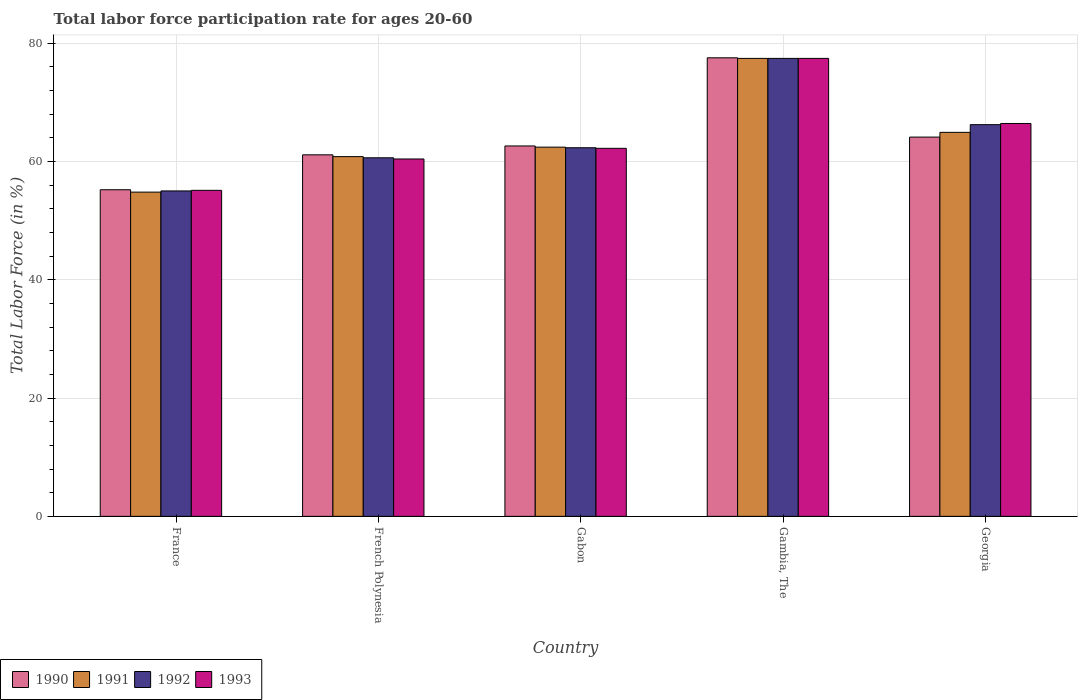How many different coloured bars are there?
Your answer should be compact. 4. How many groups of bars are there?
Provide a short and direct response. 5. Are the number of bars on each tick of the X-axis equal?
Provide a short and direct response. Yes. How many bars are there on the 5th tick from the left?
Your answer should be compact. 4. What is the label of the 4th group of bars from the left?
Your answer should be very brief. Gambia, The. What is the labor force participation rate in 1992 in France?
Keep it short and to the point. 55. Across all countries, what is the maximum labor force participation rate in 1992?
Your answer should be compact. 77.4. Across all countries, what is the minimum labor force participation rate in 1990?
Keep it short and to the point. 55.2. In which country was the labor force participation rate in 1990 maximum?
Offer a very short reply. Gambia, The. What is the total labor force participation rate in 1991 in the graph?
Your answer should be very brief. 320.3. What is the difference between the labor force participation rate in 1991 in France and that in Georgia?
Your response must be concise. -10.1. What is the difference between the labor force participation rate in 1990 in French Polynesia and the labor force participation rate in 1991 in Gabon?
Offer a terse response. -1.3. What is the average labor force participation rate in 1990 per country?
Make the answer very short. 64.1. What is the difference between the labor force participation rate of/in 1990 and labor force participation rate of/in 1993 in French Polynesia?
Provide a succinct answer. 0.7. In how many countries, is the labor force participation rate in 1992 greater than 64 %?
Your answer should be very brief. 2. What is the ratio of the labor force participation rate in 1991 in France to that in Gabon?
Your response must be concise. 0.88. Is the labor force participation rate in 1991 in French Polynesia less than that in Gambia, The?
Give a very brief answer. Yes. Is the difference between the labor force participation rate in 1990 in France and Gabon greater than the difference between the labor force participation rate in 1993 in France and Gabon?
Provide a short and direct response. No. What is the difference between the highest and the second highest labor force participation rate in 1991?
Your answer should be very brief. -12.5. What is the difference between the highest and the lowest labor force participation rate in 1993?
Offer a very short reply. 22.3. In how many countries, is the labor force participation rate in 1991 greater than the average labor force participation rate in 1991 taken over all countries?
Give a very brief answer. 2. Is the sum of the labor force participation rate in 1993 in France and Georgia greater than the maximum labor force participation rate in 1990 across all countries?
Provide a short and direct response. Yes. What does the 4th bar from the left in French Polynesia represents?
Provide a succinct answer. 1993. What does the 2nd bar from the right in Gambia, The represents?
Your answer should be very brief. 1992. How many countries are there in the graph?
Your answer should be very brief. 5. What is the difference between two consecutive major ticks on the Y-axis?
Make the answer very short. 20. Are the values on the major ticks of Y-axis written in scientific E-notation?
Keep it short and to the point. No. Does the graph contain grids?
Make the answer very short. Yes. Where does the legend appear in the graph?
Give a very brief answer. Bottom left. How many legend labels are there?
Ensure brevity in your answer.  4. What is the title of the graph?
Provide a succinct answer. Total labor force participation rate for ages 20-60. What is the label or title of the X-axis?
Make the answer very short. Country. What is the label or title of the Y-axis?
Your answer should be compact. Total Labor Force (in %). What is the Total Labor Force (in %) in 1990 in France?
Your response must be concise. 55.2. What is the Total Labor Force (in %) of 1991 in France?
Offer a very short reply. 54.8. What is the Total Labor Force (in %) of 1993 in France?
Offer a terse response. 55.1. What is the Total Labor Force (in %) of 1990 in French Polynesia?
Make the answer very short. 61.1. What is the Total Labor Force (in %) of 1991 in French Polynesia?
Provide a short and direct response. 60.8. What is the Total Labor Force (in %) in 1992 in French Polynesia?
Make the answer very short. 60.6. What is the Total Labor Force (in %) in 1993 in French Polynesia?
Provide a succinct answer. 60.4. What is the Total Labor Force (in %) in 1990 in Gabon?
Make the answer very short. 62.6. What is the Total Labor Force (in %) of 1991 in Gabon?
Offer a terse response. 62.4. What is the Total Labor Force (in %) of 1992 in Gabon?
Offer a very short reply. 62.3. What is the Total Labor Force (in %) of 1993 in Gabon?
Make the answer very short. 62.2. What is the Total Labor Force (in %) in 1990 in Gambia, The?
Your response must be concise. 77.5. What is the Total Labor Force (in %) of 1991 in Gambia, The?
Provide a succinct answer. 77.4. What is the Total Labor Force (in %) of 1992 in Gambia, The?
Your response must be concise. 77.4. What is the Total Labor Force (in %) in 1993 in Gambia, The?
Make the answer very short. 77.4. What is the Total Labor Force (in %) of 1990 in Georgia?
Give a very brief answer. 64.1. What is the Total Labor Force (in %) in 1991 in Georgia?
Your answer should be very brief. 64.9. What is the Total Labor Force (in %) in 1992 in Georgia?
Ensure brevity in your answer.  66.2. What is the Total Labor Force (in %) in 1993 in Georgia?
Keep it short and to the point. 66.4. Across all countries, what is the maximum Total Labor Force (in %) in 1990?
Offer a very short reply. 77.5. Across all countries, what is the maximum Total Labor Force (in %) of 1991?
Ensure brevity in your answer.  77.4. Across all countries, what is the maximum Total Labor Force (in %) of 1992?
Ensure brevity in your answer.  77.4. Across all countries, what is the maximum Total Labor Force (in %) in 1993?
Give a very brief answer. 77.4. Across all countries, what is the minimum Total Labor Force (in %) in 1990?
Offer a very short reply. 55.2. Across all countries, what is the minimum Total Labor Force (in %) in 1991?
Your response must be concise. 54.8. Across all countries, what is the minimum Total Labor Force (in %) in 1992?
Ensure brevity in your answer.  55. Across all countries, what is the minimum Total Labor Force (in %) of 1993?
Your response must be concise. 55.1. What is the total Total Labor Force (in %) of 1990 in the graph?
Your response must be concise. 320.5. What is the total Total Labor Force (in %) of 1991 in the graph?
Your answer should be compact. 320.3. What is the total Total Labor Force (in %) in 1992 in the graph?
Give a very brief answer. 321.5. What is the total Total Labor Force (in %) of 1993 in the graph?
Offer a very short reply. 321.5. What is the difference between the Total Labor Force (in %) in 1990 in France and that in French Polynesia?
Make the answer very short. -5.9. What is the difference between the Total Labor Force (in %) in 1992 in France and that in French Polynesia?
Your answer should be compact. -5.6. What is the difference between the Total Labor Force (in %) in 1993 in France and that in French Polynesia?
Offer a very short reply. -5.3. What is the difference between the Total Labor Force (in %) in 1992 in France and that in Gabon?
Your response must be concise. -7.3. What is the difference between the Total Labor Force (in %) in 1990 in France and that in Gambia, The?
Your answer should be compact. -22.3. What is the difference between the Total Labor Force (in %) of 1991 in France and that in Gambia, The?
Provide a succinct answer. -22.6. What is the difference between the Total Labor Force (in %) in 1992 in France and that in Gambia, The?
Your response must be concise. -22.4. What is the difference between the Total Labor Force (in %) of 1993 in France and that in Gambia, The?
Your answer should be very brief. -22.3. What is the difference between the Total Labor Force (in %) of 1991 in French Polynesia and that in Gabon?
Offer a terse response. -1.6. What is the difference between the Total Labor Force (in %) in 1992 in French Polynesia and that in Gabon?
Your answer should be very brief. -1.7. What is the difference between the Total Labor Force (in %) in 1990 in French Polynesia and that in Gambia, The?
Offer a very short reply. -16.4. What is the difference between the Total Labor Force (in %) in 1991 in French Polynesia and that in Gambia, The?
Ensure brevity in your answer.  -16.6. What is the difference between the Total Labor Force (in %) in 1992 in French Polynesia and that in Gambia, The?
Offer a terse response. -16.8. What is the difference between the Total Labor Force (in %) of 1993 in French Polynesia and that in Gambia, The?
Provide a succinct answer. -17. What is the difference between the Total Labor Force (in %) of 1990 in French Polynesia and that in Georgia?
Provide a short and direct response. -3. What is the difference between the Total Labor Force (in %) in 1990 in Gabon and that in Gambia, The?
Provide a short and direct response. -14.9. What is the difference between the Total Labor Force (in %) of 1991 in Gabon and that in Gambia, The?
Make the answer very short. -15. What is the difference between the Total Labor Force (in %) of 1992 in Gabon and that in Gambia, The?
Provide a succinct answer. -15.1. What is the difference between the Total Labor Force (in %) in 1993 in Gabon and that in Gambia, The?
Offer a very short reply. -15.2. What is the difference between the Total Labor Force (in %) of 1991 in Gabon and that in Georgia?
Your answer should be very brief. -2.5. What is the difference between the Total Labor Force (in %) of 1990 in Gambia, The and that in Georgia?
Keep it short and to the point. 13.4. What is the difference between the Total Labor Force (in %) of 1991 in Gambia, The and that in Georgia?
Provide a succinct answer. 12.5. What is the difference between the Total Labor Force (in %) in 1993 in Gambia, The and that in Georgia?
Your answer should be very brief. 11. What is the difference between the Total Labor Force (in %) in 1990 in France and the Total Labor Force (in %) in 1992 in French Polynesia?
Provide a succinct answer. -5.4. What is the difference between the Total Labor Force (in %) in 1990 in France and the Total Labor Force (in %) in 1993 in French Polynesia?
Your answer should be very brief. -5.2. What is the difference between the Total Labor Force (in %) in 1991 in France and the Total Labor Force (in %) in 1992 in French Polynesia?
Provide a short and direct response. -5.8. What is the difference between the Total Labor Force (in %) in 1991 in France and the Total Labor Force (in %) in 1993 in French Polynesia?
Offer a very short reply. -5.6. What is the difference between the Total Labor Force (in %) of 1992 in France and the Total Labor Force (in %) of 1993 in French Polynesia?
Give a very brief answer. -5.4. What is the difference between the Total Labor Force (in %) in 1990 in France and the Total Labor Force (in %) in 1993 in Gabon?
Provide a short and direct response. -7. What is the difference between the Total Labor Force (in %) of 1991 in France and the Total Labor Force (in %) of 1992 in Gabon?
Make the answer very short. -7.5. What is the difference between the Total Labor Force (in %) in 1991 in France and the Total Labor Force (in %) in 1993 in Gabon?
Give a very brief answer. -7.4. What is the difference between the Total Labor Force (in %) in 1990 in France and the Total Labor Force (in %) in 1991 in Gambia, The?
Offer a very short reply. -22.2. What is the difference between the Total Labor Force (in %) of 1990 in France and the Total Labor Force (in %) of 1992 in Gambia, The?
Give a very brief answer. -22.2. What is the difference between the Total Labor Force (in %) in 1990 in France and the Total Labor Force (in %) in 1993 in Gambia, The?
Provide a succinct answer. -22.2. What is the difference between the Total Labor Force (in %) of 1991 in France and the Total Labor Force (in %) of 1992 in Gambia, The?
Offer a terse response. -22.6. What is the difference between the Total Labor Force (in %) in 1991 in France and the Total Labor Force (in %) in 1993 in Gambia, The?
Your answer should be very brief. -22.6. What is the difference between the Total Labor Force (in %) in 1992 in France and the Total Labor Force (in %) in 1993 in Gambia, The?
Provide a succinct answer. -22.4. What is the difference between the Total Labor Force (in %) in 1991 in France and the Total Labor Force (in %) in 1992 in Georgia?
Keep it short and to the point. -11.4. What is the difference between the Total Labor Force (in %) in 1991 in France and the Total Labor Force (in %) in 1993 in Georgia?
Your answer should be compact. -11.6. What is the difference between the Total Labor Force (in %) of 1992 in French Polynesia and the Total Labor Force (in %) of 1993 in Gabon?
Your answer should be very brief. -1.6. What is the difference between the Total Labor Force (in %) in 1990 in French Polynesia and the Total Labor Force (in %) in 1991 in Gambia, The?
Provide a short and direct response. -16.3. What is the difference between the Total Labor Force (in %) in 1990 in French Polynesia and the Total Labor Force (in %) in 1992 in Gambia, The?
Offer a very short reply. -16.3. What is the difference between the Total Labor Force (in %) of 1990 in French Polynesia and the Total Labor Force (in %) of 1993 in Gambia, The?
Provide a short and direct response. -16.3. What is the difference between the Total Labor Force (in %) of 1991 in French Polynesia and the Total Labor Force (in %) of 1992 in Gambia, The?
Your answer should be compact. -16.6. What is the difference between the Total Labor Force (in %) in 1991 in French Polynesia and the Total Labor Force (in %) in 1993 in Gambia, The?
Provide a succinct answer. -16.6. What is the difference between the Total Labor Force (in %) in 1992 in French Polynesia and the Total Labor Force (in %) in 1993 in Gambia, The?
Offer a very short reply. -16.8. What is the difference between the Total Labor Force (in %) in 1990 in French Polynesia and the Total Labor Force (in %) in 1991 in Georgia?
Offer a very short reply. -3.8. What is the difference between the Total Labor Force (in %) in 1990 in French Polynesia and the Total Labor Force (in %) in 1992 in Georgia?
Your answer should be compact. -5.1. What is the difference between the Total Labor Force (in %) of 1990 in French Polynesia and the Total Labor Force (in %) of 1993 in Georgia?
Offer a very short reply. -5.3. What is the difference between the Total Labor Force (in %) of 1991 in French Polynesia and the Total Labor Force (in %) of 1992 in Georgia?
Ensure brevity in your answer.  -5.4. What is the difference between the Total Labor Force (in %) of 1990 in Gabon and the Total Labor Force (in %) of 1991 in Gambia, The?
Your answer should be compact. -14.8. What is the difference between the Total Labor Force (in %) in 1990 in Gabon and the Total Labor Force (in %) in 1992 in Gambia, The?
Make the answer very short. -14.8. What is the difference between the Total Labor Force (in %) in 1990 in Gabon and the Total Labor Force (in %) in 1993 in Gambia, The?
Make the answer very short. -14.8. What is the difference between the Total Labor Force (in %) of 1991 in Gabon and the Total Labor Force (in %) of 1993 in Gambia, The?
Keep it short and to the point. -15. What is the difference between the Total Labor Force (in %) of 1992 in Gabon and the Total Labor Force (in %) of 1993 in Gambia, The?
Keep it short and to the point. -15.1. What is the difference between the Total Labor Force (in %) in 1990 in Gabon and the Total Labor Force (in %) in 1991 in Georgia?
Make the answer very short. -2.3. What is the difference between the Total Labor Force (in %) in 1990 in Gabon and the Total Labor Force (in %) in 1993 in Georgia?
Your answer should be very brief. -3.8. What is the difference between the Total Labor Force (in %) of 1991 in Gabon and the Total Labor Force (in %) of 1993 in Georgia?
Your answer should be very brief. -4. What is the difference between the Total Labor Force (in %) in 1992 in Gabon and the Total Labor Force (in %) in 1993 in Georgia?
Give a very brief answer. -4.1. What is the difference between the Total Labor Force (in %) of 1990 in Gambia, The and the Total Labor Force (in %) of 1991 in Georgia?
Your response must be concise. 12.6. What is the difference between the Total Labor Force (in %) in 1990 in Gambia, The and the Total Labor Force (in %) in 1992 in Georgia?
Give a very brief answer. 11.3. What is the difference between the Total Labor Force (in %) of 1991 in Gambia, The and the Total Labor Force (in %) of 1992 in Georgia?
Your answer should be compact. 11.2. What is the difference between the Total Labor Force (in %) of 1991 in Gambia, The and the Total Labor Force (in %) of 1993 in Georgia?
Keep it short and to the point. 11. What is the difference between the Total Labor Force (in %) in 1992 in Gambia, The and the Total Labor Force (in %) in 1993 in Georgia?
Offer a very short reply. 11. What is the average Total Labor Force (in %) in 1990 per country?
Your response must be concise. 64.1. What is the average Total Labor Force (in %) in 1991 per country?
Provide a short and direct response. 64.06. What is the average Total Labor Force (in %) of 1992 per country?
Offer a terse response. 64.3. What is the average Total Labor Force (in %) of 1993 per country?
Offer a very short reply. 64.3. What is the difference between the Total Labor Force (in %) of 1990 and Total Labor Force (in %) of 1991 in France?
Offer a very short reply. 0.4. What is the difference between the Total Labor Force (in %) of 1990 and Total Labor Force (in %) of 1993 in France?
Your answer should be compact. 0.1. What is the difference between the Total Labor Force (in %) in 1991 and Total Labor Force (in %) in 1993 in France?
Offer a very short reply. -0.3. What is the difference between the Total Labor Force (in %) in 1990 and Total Labor Force (in %) in 1992 in French Polynesia?
Offer a terse response. 0.5. What is the difference between the Total Labor Force (in %) in 1991 and Total Labor Force (in %) in 1993 in French Polynesia?
Your answer should be very brief. 0.4. What is the difference between the Total Labor Force (in %) in 1990 and Total Labor Force (in %) in 1992 in Gabon?
Provide a short and direct response. 0.3. What is the difference between the Total Labor Force (in %) of 1990 and Total Labor Force (in %) of 1993 in Gabon?
Provide a short and direct response. 0.4. What is the difference between the Total Labor Force (in %) in 1991 and Total Labor Force (in %) in 1992 in Gabon?
Your response must be concise. 0.1. What is the difference between the Total Labor Force (in %) of 1991 and Total Labor Force (in %) of 1993 in Gabon?
Give a very brief answer. 0.2. What is the difference between the Total Labor Force (in %) of 1990 and Total Labor Force (in %) of 1991 in Gambia, The?
Provide a succinct answer. 0.1. What is the difference between the Total Labor Force (in %) of 1990 and Total Labor Force (in %) of 1992 in Gambia, The?
Make the answer very short. 0.1. What is the difference between the Total Labor Force (in %) in 1990 and Total Labor Force (in %) in 1993 in Gambia, The?
Make the answer very short. 0.1. What is the difference between the Total Labor Force (in %) in 1991 and Total Labor Force (in %) in 1992 in Gambia, The?
Provide a succinct answer. 0. What is the difference between the Total Labor Force (in %) in 1991 and Total Labor Force (in %) in 1993 in Gambia, The?
Your answer should be very brief. 0. What is the difference between the Total Labor Force (in %) in 1990 and Total Labor Force (in %) in 1991 in Georgia?
Your response must be concise. -0.8. What is the difference between the Total Labor Force (in %) of 1990 and Total Labor Force (in %) of 1992 in Georgia?
Provide a short and direct response. -2.1. What is the difference between the Total Labor Force (in %) in 1992 and Total Labor Force (in %) in 1993 in Georgia?
Your answer should be very brief. -0.2. What is the ratio of the Total Labor Force (in %) of 1990 in France to that in French Polynesia?
Ensure brevity in your answer.  0.9. What is the ratio of the Total Labor Force (in %) of 1991 in France to that in French Polynesia?
Provide a short and direct response. 0.9. What is the ratio of the Total Labor Force (in %) of 1992 in France to that in French Polynesia?
Your answer should be compact. 0.91. What is the ratio of the Total Labor Force (in %) of 1993 in France to that in French Polynesia?
Give a very brief answer. 0.91. What is the ratio of the Total Labor Force (in %) in 1990 in France to that in Gabon?
Provide a short and direct response. 0.88. What is the ratio of the Total Labor Force (in %) in 1991 in France to that in Gabon?
Provide a short and direct response. 0.88. What is the ratio of the Total Labor Force (in %) in 1992 in France to that in Gabon?
Keep it short and to the point. 0.88. What is the ratio of the Total Labor Force (in %) in 1993 in France to that in Gabon?
Your answer should be compact. 0.89. What is the ratio of the Total Labor Force (in %) in 1990 in France to that in Gambia, The?
Your response must be concise. 0.71. What is the ratio of the Total Labor Force (in %) in 1991 in France to that in Gambia, The?
Provide a succinct answer. 0.71. What is the ratio of the Total Labor Force (in %) in 1992 in France to that in Gambia, The?
Your response must be concise. 0.71. What is the ratio of the Total Labor Force (in %) of 1993 in France to that in Gambia, The?
Make the answer very short. 0.71. What is the ratio of the Total Labor Force (in %) in 1990 in France to that in Georgia?
Your answer should be very brief. 0.86. What is the ratio of the Total Labor Force (in %) of 1991 in France to that in Georgia?
Provide a short and direct response. 0.84. What is the ratio of the Total Labor Force (in %) in 1992 in France to that in Georgia?
Provide a short and direct response. 0.83. What is the ratio of the Total Labor Force (in %) in 1993 in France to that in Georgia?
Make the answer very short. 0.83. What is the ratio of the Total Labor Force (in %) in 1990 in French Polynesia to that in Gabon?
Provide a succinct answer. 0.98. What is the ratio of the Total Labor Force (in %) of 1991 in French Polynesia to that in Gabon?
Your answer should be compact. 0.97. What is the ratio of the Total Labor Force (in %) of 1992 in French Polynesia to that in Gabon?
Provide a succinct answer. 0.97. What is the ratio of the Total Labor Force (in %) of 1993 in French Polynesia to that in Gabon?
Your answer should be compact. 0.97. What is the ratio of the Total Labor Force (in %) of 1990 in French Polynesia to that in Gambia, The?
Provide a succinct answer. 0.79. What is the ratio of the Total Labor Force (in %) in 1991 in French Polynesia to that in Gambia, The?
Provide a short and direct response. 0.79. What is the ratio of the Total Labor Force (in %) of 1992 in French Polynesia to that in Gambia, The?
Offer a very short reply. 0.78. What is the ratio of the Total Labor Force (in %) of 1993 in French Polynesia to that in Gambia, The?
Your answer should be very brief. 0.78. What is the ratio of the Total Labor Force (in %) of 1990 in French Polynesia to that in Georgia?
Your response must be concise. 0.95. What is the ratio of the Total Labor Force (in %) of 1991 in French Polynesia to that in Georgia?
Offer a terse response. 0.94. What is the ratio of the Total Labor Force (in %) of 1992 in French Polynesia to that in Georgia?
Your answer should be compact. 0.92. What is the ratio of the Total Labor Force (in %) in 1993 in French Polynesia to that in Georgia?
Offer a terse response. 0.91. What is the ratio of the Total Labor Force (in %) of 1990 in Gabon to that in Gambia, The?
Your answer should be compact. 0.81. What is the ratio of the Total Labor Force (in %) in 1991 in Gabon to that in Gambia, The?
Offer a very short reply. 0.81. What is the ratio of the Total Labor Force (in %) in 1992 in Gabon to that in Gambia, The?
Your answer should be compact. 0.8. What is the ratio of the Total Labor Force (in %) in 1993 in Gabon to that in Gambia, The?
Give a very brief answer. 0.8. What is the ratio of the Total Labor Force (in %) of 1990 in Gabon to that in Georgia?
Keep it short and to the point. 0.98. What is the ratio of the Total Labor Force (in %) of 1991 in Gabon to that in Georgia?
Make the answer very short. 0.96. What is the ratio of the Total Labor Force (in %) in 1992 in Gabon to that in Georgia?
Offer a terse response. 0.94. What is the ratio of the Total Labor Force (in %) in 1993 in Gabon to that in Georgia?
Keep it short and to the point. 0.94. What is the ratio of the Total Labor Force (in %) of 1990 in Gambia, The to that in Georgia?
Your answer should be very brief. 1.21. What is the ratio of the Total Labor Force (in %) of 1991 in Gambia, The to that in Georgia?
Make the answer very short. 1.19. What is the ratio of the Total Labor Force (in %) of 1992 in Gambia, The to that in Georgia?
Give a very brief answer. 1.17. What is the ratio of the Total Labor Force (in %) in 1993 in Gambia, The to that in Georgia?
Make the answer very short. 1.17. What is the difference between the highest and the second highest Total Labor Force (in %) of 1991?
Your answer should be very brief. 12.5. What is the difference between the highest and the second highest Total Labor Force (in %) in 1993?
Offer a very short reply. 11. What is the difference between the highest and the lowest Total Labor Force (in %) in 1990?
Provide a succinct answer. 22.3. What is the difference between the highest and the lowest Total Labor Force (in %) of 1991?
Your answer should be compact. 22.6. What is the difference between the highest and the lowest Total Labor Force (in %) of 1992?
Offer a very short reply. 22.4. What is the difference between the highest and the lowest Total Labor Force (in %) of 1993?
Provide a short and direct response. 22.3. 